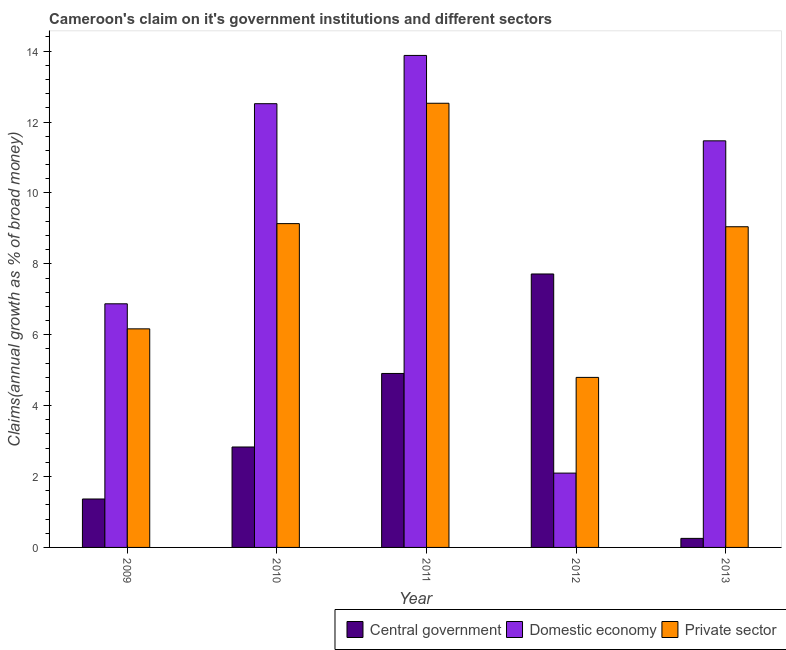How many groups of bars are there?
Your answer should be very brief. 5. Are the number of bars per tick equal to the number of legend labels?
Offer a very short reply. Yes. Are the number of bars on each tick of the X-axis equal?
Your answer should be compact. Yes. What is the percentage of claim on the private sector in 2013?
Your answer should be compact. 9.05. Across all years, what is the maximum percentage of claim on the private sector?
Offer a terse response. 12.53. Across all years, what is the minimum percentage of claim on the central government?
Your answer should be compact. 0.25. In which year was the percentage of claim on the private sector minimum?
Offer a terse response. 2012. What is the total percentage of claim on the private sector in the graph?
Your response must be concise. 41.67. What is the difference between the percentage of claim on the private sector in 2009 and that in 2010?
Ensure brevity in your answer.  -2.97. What is the difference between the percentage of claim on the private sector in 2011 and the percentage of claim on the central government in 2012?
Keep it short and to the point. 7.73. What is the average percentage of claim on the domestic economy per year?
Your response must be concise. 9.37. In the year 2010, what is the difference between the percentage of claim on the private sector and percentage of claim on the domestic economy?
Your answer should be very brief. 0. What is the ratio of the percentage of claim on the central government in 2009 to that in 2012?
Provide a succinct answer. 0.18. What is the difference between the highest and the second highest percentage of claim on the domestic economy?
Provide a short and direct response. 1.36. What is the difference between the highest and the lowest percentage of claim on the private sector?
Provide a short and direct response. 7.73. In how many years, is the percentage of claim on the private sector greater than the average percentage of claim on the private sector taken over all years?
Provide a succinct answer. 3. What does the 1st bar from the left in 2013 represents?
Ensure brevity in your answer.  Central government. What does the 2nd bar from the right in 2011 represents?
Your response must be concise. Domestic economy. How many bars are there?
Make the answer very short. 15. How many years are there in the graph?
Your answer should be compact. 5. What is the difference between two consecutive major ticks on the Y-axis?
Your answer should be compact. 2. What is the title of the graph?
Keep it short and to the point. Cameroon's claim on it's government institutions and different sectors. What is the label or title of the X-axis?
Make the answer very short. Year. What is the label or title of the Y-axis?
Give a very brief answer. Claims(annual growth as % of broad money). What is the Claims(annual growth as % of broad money) in Central government in 2009?
Give a very brief answer. 1.37. What is the Claims(annual growth as % of broad money) of Domestic economy in 2009?
Keep it short and to the point. 6.87. What is the Claims(annual growth as % of broad money) of Private sector in 2009?
Offer a very short reply. 6.17. What is the Claims(annual growth as % of broad money) in Central government in 2010?
Keep it short and to the point. 2.83. What is the Claims(annual growth as % of broad money) in Domestic economy in 2010?
Offer a terse response. 12.52. What is the Claims(annual growth as % of broad money) in Private sector in 2010?
Your answer should be compact. 9.13. What is the Claims(annual growth as % of broad money) in Central government in 2011?
Offer a terse response. 4.91. What is the Claims(annual growth as % of broad money) in Domestic economy in 2011?
Your answer should be compact. 13.88. What is the Claims(annual growth as % of broad money) of Private sector in 2011?
Your answer should be compact. 12.53. What is the Claims(annual growth as % of broad money) of Central government in 2012?
Keep it short and to the point. 7.71. What is the Claims(annual growth as % of broad money) in Domestic economy in 2012?
Ensure brevity in your answer.  2.1. What is the Claims(annual growth as % of broad money) of Private sector in 2012?
Make the answer very short. 4.8. What is the Claims(annual growth as % of broad money) of Central government in 2013?
Provide a short and direct response. 0.25. What is the Claims(annual growth as % of broad money) of Domestic economy in 2013?
Provide a succinct answer. 11.47. What is the Claims(annual growth as % of broad money) of Private sector in 2013?
Provide a short and direct response. 9.05. Across all years, what is the maximum Claims(annual growth as % of broad money) of Central government?
Your response must be concise. 7.71. Across all years, what is the maximum Claims(annual growth as % of broad money) of Domestic economy?
Offer a very short reply. 13.88. Across all years, what is the maximum Claims(annual growth as % of broad money) of Private sector?
Provide a succinct answer. 12.53. Across all years, what is the minimum Claims(annual growth as % of broad money) in Central government?
Provide a succinct answer. 0.25. Across all years, what is the minimum Claims(annual growth as % of broad money) of Domestic economy?
Provide a succinct answer. 2.1. Across all years, what is the minimum Claims(annual growth as % of broad money) in Private sector?
Your response must be concise. 4.8. What is the total Claims(annual growth as % of broad money) of Central government in the graph?
Provide a succinct answer. 17.08. What is the total Claims(annual growth as % of broad money) in Domestic economy in the graph?
Keep it short and to the point. 46.83. What is the total Claims(annual growth as % of broad money) of Private sector in the graph?
Keep it short and to the point. 41.67. What is the difference between the Claims(annual growth as % of broad money) in Central government in 2009 and that in 2010?
Ensure brevity in your answer.  -1.47. What is the difference between the Claims(annual growth as % of broad money) in Domestic economy in 2009 and that in 2010?
Ensure brevity in your answer.  -5.64. What is the difference between the Claims(annual growth as % of broad money) of Private sector in 2009 and that in 2010?
Keep it short and to the point. -2.97. What is the difference between the Claims(annual growth as % of broad money) of Central government in 2009 and that in 2011?
Give a very brief answer. -3.54. What is the difference between the Claims(annual growth as % of broad money) of Domestic economy in 2009 and that in 2011?
Offer a terse response. -7.01. What is the difference between the Claims(annual growth as % of broad money) in Private sector in 2009 and that in 2011?
Your answer should be compact. -6.36. What is the difference between the Claims(annual growth as % of broad money) of Central government in 2009 and that in 2012?
Your answer should be very brief. -6.35. What is the difference between the Claims(annual growth as % of broad money) in Domestic economy in 2009 and that in 2012?
Your answer should be compact. 4.78. What is the difference between the Claims(annual growth as % of broad money) in Private sector in 2009 and that in 2012?
Ensure brevity in your answer.  1.37. What is the difference between the Claims(annual growth as % of broad money) in Central government in 2009 and that in 2013?
Give a very brief answer. 1.11. What is the difference between the Claims(annual growth as % of broad money) of Domestic economy in 2009 and that in 2013?
Make the answer very short. -4.6. What is the difference between the Claims(annual growth as % of broad money) in Private sector in 2009 and that in 2013?
Ensure brevity in your answer.  -2.88. What is the difference between the Claims(annual growth as % of broad money) in Central government in 2010 and that in 2011?
Ensure brevity in your answer.  -2.07. What is the difference between the Claims(annual growth as % of broad money) of Domestic economy in 2010 and that in 2011?
Make the answer very short. -1.36. What is the difference between the Claims(annual growth as % of broad money) of Private sector in 2010 and that in 2011?
Ensure brevity in your answer.  -3.4. What is the difference between the Claims(annual growth as % of broad money) in Central government in 2010 and that in 2012?
Ensure brevity in your answer.  -4.88. What is the difference between the Claims(annual growth as % of broad money) in Domestic economy in 2010 and that in 2012?
Your answer should be compact. 10.42. What is the difference between the Claims(annual growth as % of broad money) of Private sector in 2010 and that in 2012?
Your answer should be very brief. 4.34. What is the difference between the Claims(annual growth as % of broad money) of Central government in 2010 and that in 2013?
Provide a short and direct response. 2.58. What is the difference between the Claims(annual growth as % of broad money) in Domestic economy in 2010 and that in 2013?
Your answer should be compact. 1.05. What is the difference between the Claims(annual growth as % of broad money) in Private sector in 2010 and that in 2013?
Ensure brevity in your answer.  0.09. What is the difference between the Claims(annual growth as % of broad money) in Central government in 2011 and that in 2012?
Provide a short and direct response. -2.81. What is the difference between the Claims(annual growth as % of broad money) in Domestic economy in 2011 and that in 2012?
Your answer should be compact. 11.78. What is the difference between the Claims(annual growth as % of broad money) of Private sector in 2011 and that in 2012?
Keep it short and to the point. 7.73. What is the difference between the Claims(annual growth as % of broad money) in Central government in 2011 and that in 2013?
Your answer should be very brief. 4.65. What is the difference between the Claims(annual growth as % of broad money) of Domestic economy in 2011 and that in 2013?
Offer a very short reply. 2.41. What is the difference between the Claims(annual growth as % of broad money) in Private sector in 2011 and that in 2013?
Keep it short and to the point. 3.48. What is the difference between the Claims(annual growth as % of broad money) of Central government in 2012 and that in 2013?
Provide a short and direct response. 7.46. What is the difference between the Claims(annual growth as % of broad money) in Domestic economy in 2012 and that in 2013?
Your answer should be compact. -9.37. What is the difference between the Claims(annual growth as % of broad money) in Private sector in 2012 and that in 2013?
Provide a short and direct response. -4.25. What is the difference between the Claims(annual growth as % of broad money) in Central government in 2009 and the Claims(annual growth as % of broad money) in Domestic economy in 2010?
Give a very brief answer. -11.15. What is the difference between the Claims(annual growth as % of broad money) of Central government in 2009 and the Claims(annual growth as % of broad money) of Private sector in 2010?
Provide a short and direct response. -7.77. What is the difference between the Claims(annual growth as % of broad money) in Domestic economy in 2009 and the Claims(annual growth as % of broad money) in Private sector in 2010?
Your answer should be very brief. -2.26. What is the difference between the Claims(annual growth as % of broad money) of Central government in 2009 and the Claims(annual growth as % of broad money) of Domestic economy in 2011?
Offer a very short reply. -12.51. What is the difference between the Claims(annual growth as % of broad money) in Central government in 2009 and the Claims(annual growth as % of broad money) in Private sector in 2011?
Offer a terse response. -11.16. What is the difference between the Claims(annual growth as % of broad money) in Domestic economy in 2009 and the Claims(annual growth as % of broad money) in Private sector in 2011?
Provide a succinct answer. -5.66. What is the difference between the Claims(annual growth as % of broad money) of Central government in 2009 and the Claims(annual growth as % of broad money) of Domestic economy in 2012?
Make the answer very short. -0.73. What is the difference between the Claims(annual growth as % of broad money) in Central government in 2009 and the Claims(annual growth as % of broad money) in Private sector in 2012?
Your response must be concise. -3.43. What is the difference between the Claims(annual growth as % of broad money) in Domestic economy in 2009 and the Claims(annual growth as % of broad money) in Private sector in 2012?
Make the answer very short. 2.08. What is the difference between the Claims(annual growth as % of broad money) in Central government in 2009 and the Claims(annual growth as % of broad money) in Domestic economy in 2013?
Keep it short and to the point. -10.1. What is the difference between the Claims(annual growth as % of broad money) in Central government in 2009 and the Claims(annual growth as % of broad money) in Private sector in 2013?
Your response must be concise. -7.68. What is the difference between the Claims(annual growth as % of broad money) of Domestic economy in 2009 and the Claims(annual growth as % of broad money) of Private sector in 2013?
Offer a very short reply. -2.17. What is the difference between the Claims(annual growth as % of broad money) of Central government in 2010 and the Claims(annual growth as % of broad money) of Domestic economy in 2011?
Ensure brevity in your answer.  -11.05. What is the difference between the Claims(annual growth as % of broad money) in Central government in 2010 and the Claims(annual growth as % of broad money) in Private sector in 2011?
Keep it short and to the point. -9.7. What is the difference between the Claims(annual growth as % of broad money) in Domestic economy in 2010 and the Claims(annual growth as % of broad money) in Private sector in 2011?
Ensure brevity in your answer.  -0.01. What is the difference between the Claims(annual growth as % of broad money) of Central government in 2010 and the Claims(annual growth as % of broad money) of Domestic economy in 2012?
Your answer should be compact. 0.74. What is the difference between the Claims(annual growth as % of broad money) of Central government in 2010 and the Claims(annual growth as % of broad money) of Private sector in 2012?
Offer a very short reply. -1.96. What is the difference between the Claims(annual growth as % of broad money) of Domestic economy in 2010 and the Claims(annual growth as % of broad money) of Private sector in 2012?
Provide a succinct answer. 7.72. What is the difference between the Claims(annual growth as % of broad money) in Central government in 2010 and the Claims(annual growth as % of broad money) in Domestic economy in 2013?
Give a very brief answer. -8.64. What is the difference between the Claims(annual growth as % of broad money) in Central government in 2010 and the Claims(annual growth as % of broad money) in Private sector in 2013?
Ensure brevity in your answer.  -6.21. What is the difference between the Claims(annual growth as % of broad money) of Domestic economy in 2010 and the Claims(annual growth as % of broad money) of Private sector in 2013?
Provide a short and direct response. 3.47. What is the difference between the Claims(annual growth as % of broad money) in Central government in 2011 and the Claims(annual growth as % of broad money) in Domestic economy in 2012?
Give a very brief answer. 2.81. What is the difference between the Claims(annual growth as % of broad money) of Central government in 2011 and the Claims(annual growth as % of broad money) of Private sector in 2012?
Provide a short and direct response. 0.11. What is the difference between the Claims(annual growth as % of broad money) in Domestic economy in 2011 and the Claims(annual growth as % of broad money) in Private sector in 2012?
Give a very brief answer. 9.08. What is the difference between the Claims(annual growth as % of broad money) in Central government in 2011 and the Claims(annual growth as % of broad money) in Domestic economy in 2013?
Make the answer very short. -6.56. What is the difference between the Claims(annual growth as % of broad money) in Central government in 2011 and the Claims(annual growth as % of broad money) in Private sector in 2013?
Keep it short and to the point. -4.14. What is the difference between the Claims(annual growth as % of broad money) of Domestic economy in 2011 and the Claims(annual growth as % of broad money) of Private sector in 2013?
Give a very brief answer. 4.83. What is the difference between the Claims(annual growth as % of broad money) of Central government in 2012 and the Claims(annual growth as % of broad money) of Domestic economy in 2013?
Give a very brief answer. -3.76. What is the difference between the Claims(annual growth as % of broad money) of Central government in 2012 and the Claims(annual growth as % of broad money) of Private sector in 2013?
Offer a very short reply. -1.33. What is the difference between the Claims(annual growth as % of broad money) of Domestic economy in 2012 and the Claims(annual growth as % of broad money) of Private sector in 2013?
Offer a terse response. -6.95. What is the average Claims(annual growth as % of broad money) of Central government per year?
Ensure brevity in your answer.  3.42. What is the average Claims(annual growth as % of broad money) in Domestic economy per year?
Your answer should be very brief. 9.37. What is the average Claims(annual growth as % of broad money) in Private sector per year?
Ensure brevity in your answer.  8.33. In the year 2009, what is the difference between the Claims(annual growth as % of broad money) in Central government and Claims(annual growth as % of broad money) in Domestic economy?
Provide a short and direct response. -5.51. In the year 2009, what is the difference between the Claims(annual growth as % of broad money) of Central government and Claims(annual growth as % of broad money) of Private sector?
Your answer should be very brief. -4.8. In the year 2009, what is the difference between the Claims(annual growth as % of broad money) in Domestic economy and Claims(annual growth as % of broad money) in Private sector?
Make the answer very short. 0.71. In the year 2010, what is the difference between the Claims(annual growth as % of broad money) of Central government and Claims(annual growth as % of broad money) of Domestic economy?
Make the answer very short. -9.68. In the year 2010, what is the difference between the Claims(annual growth as % of broad money) in Central government and Claims(annual growth as % of broad money) in Private sector?
Your answer should be very brief. -6.3. In the year 2010, what is the difference between the Claims(annual growth as % of broad money) in Domestic economy and Claims(annual growth as % of broad money) in Private sector?
Ensure brevity in your answer.  3.38. In the year 2011, what is the difference between the Claims(annual growth as % of broad money) in Central government and Claims(annual growth as % of broad money) in Domestic economy?
Your response must be concise. -8.97. In the year 2011, what is the difference between the Claims(annual growth as % of broad money) in Central government and Claims(annual growth as % of broad money) in Private sector?
Ensure brevity in your answer.  -7.62. In the year 2011, what is the difference between the Claims(annual growth as % of broad money) in Domestic economy and Claims(annual growth as % of broad money) in Private sector?
Give a very brief answer. 1.35. In the year 2012, what is the difference between the Claims(annual growth as % of broad money) of Central government and Claims(annual growth as % of broad money) of Domestic economy?
Offer a terse response. 5.62. In the year 2012, what is the difference between the Claims(annual growth as % of broad money) in Central government and Claims(annual growth as % of broad money) in Private sector?
Your answer should be compact. 2.92. In the year 2012, what is the difference between the Claims(annual growth as % of broad money) in Domestic economy and Claims(annual growth as % of broad money) in Private sector?
Make the answer very short. -2.7. In the year 2013, what is the difference between the Claims(annual growth as % of broad money) of Central government and Claims(annual growth as % of broad money) of Domestic economy?
Your response must be concise. -11.21. In the year 2013, what is the difference between the Claims(annual growth as % of broad money) of Central government and Claims(annual growth as % of broad money) of Private sector?
Ensure brevity in your answer.  -8.79. In the year 2013, what is the difference between the Claims(annual growth as % of broad money) of Domestic economy and Claims(annual growth as % of broad money) of Private sector?
Provide a short and direct response. 2.42. What is the ratio of the Claims(annual growth as % of broad money) in Central government in 2009 to that in 2010?
Offer a very short reply. 0.48. What is the ratio of the Claims(annual growth as % of broad money) of Domestic economy in 2009 to that in 2010?
Make the answer very short. 0.55. What is the ratio of the Claims(annual growth as % of broad money) of Private sector in 2009 to that in 2010?
Provide a succinct answer. 0.68. What is the ratio of the Claims(annual growth as % of broad money) of Central government in 2009 to that in 2011?
Offer a terse response. 0.28. What is the ratio of the Claims(annual growth as % of broad money) of Domestic economy in 2009 to that in 2011?
Your answer should be very brief. 0.5. What is the ratio of the Claims(annual growth as % of broad money) in Private sector in 2009 to that in 2011?
Provide a succinct answer. 0.49. What is the ratio of the Claims(annual growth as % of broad money) in Central government in 2009 to that in 2012?
Ensure brevity in your answer.  0.18. What is the ratio of the Claims(annual growth as % of broad money) of Domestic economy in 2009 to that in 2012?
Your answer should be compact. 3.28. What is the ratio of the Claims(annual growth as % of broad money) in Private sector in 2009 to that in 2012?
Your answer should be very brief. 1.29. What is the ratio of the Claims(annual growth as % of broad money) of Central government in 2009 to that in 2013?
Offer a very short reply. 5.36. What is the ratio of the Claims(annual growth as % of broad money) of Domestic economy in 2009 to that in 2013?
Offer a terse response. 0.6. What is the ratio of the Claims(annual growth as % of broad money) of Private sector in 2009 to that in 2013?
Keep it short and to the point. 0.68. What is the ratio of the Claims(annual growth as % of broad money) of Central government in 2010 to that in 2011?
Your response must be concise. 0.58. What is the ratio of the Claims(annual growth as % of broad money) in Domestic economy in 2010 to that in 2011?
Your answer should be very brief. 0.9. What is the ratio of the Claims(annual growth as % of broad money) in Private sector in 2010 to that in 2011?
Provide a succinct answer. 0.73. What is the ratio of the Claims(annual growth as % of broad money) in Central government in 2010 to that in 2012?
Make the answer very short. 0.37. What is the ratio of the Claims(annual growth as % of broad money) in Domestic economy in 2010 to that in 2012?
Make the answer very short. 5.97. What is the ratio of the Claims(annual growth as % of broad money) in Private sector in 2010 to that in 2012?
Your answer should be compact. 1.9. What is the ratio of the Claims(annual growth as % of broad money) of Central government in 2010 to that in 2013?
Your response must be concise. 11.11. What is the ratio of the Claims(annual growth as % of broad money) in Domestic economy in 2010 to that in 2013?
Make the answer very short. 1.09. What is the ratio of the Claims(annual growth as % of broad money) of Private sector in 2010 to that in 2013?
Give a very brief answer. 1.01. What is the ratio of the Claims(annual growth as % of broad money) in Central government in 2011 to that in 2012?
Provide a succinct answer. 0.64. What is the ratio of the Claims(annual growth as % of broad money) in Domestic economy in 2011 to that in 2012?
Provide a succinct answer. 6.62. What is the ratio of the Claims(annual growth as % of broad money) of Private sector in 2011 to that in 2012?
Provide a succinct answer. 2.61. What is the ratio of the Claims(annual growth as % of broad money) in Central government in 2011 to that in 2013?
Your answer should be compact. 19.25. What is the ratio of the Claims(annual growth as % of broad money) of Domestic economy in 2011 to that in 2013?
Offer a terse response. 1.21. What is the ratio of the Claims(annual growth as % of broad money) of Private sector in 2011 to that in 2013?
Keep it short and to the point. 1.39. What is the ratio of the Claims(annual growth as % of broad money) in Central government in 2012 to that in 2013?
Provide a succinct answer. 30.25. What is the ratio of the Claims(annual growth as % of broad money) in Domestic economy in 2012 to that in 2013?
Your response must be concise. 0.18. What is the ratio of the Claims(annual growth as % of broad money) of Private sector in 2012 to that in 2013?
Keep it short and to the point. 0.53. What is the difference between the highest and the second highest Claims(annual growth as % of broad money) in Central government?
Ensure brevity in your answer.  2.81. What is the difference between the highest and the second highest Claims(annual growth as % of broad money) in Domestic economy?
Offer a very short reply. 1.36. What is the difference between the highest and the second highest Claims(annual growth as % of broad money) of Private sector?
Provide a short and direct response. 3.4. What is the difference between the highest and the lowest Claims(annual growth as % of broad money) of Central government?
Offer a very short reply. 7.46. What is the difference between the highest and the lowest Claims(annual growth as % of broad money) in Domestic economy?
Ensure brevity in your answer.  11.78. What is the difference between the highest and the lowest Claims(annual growth as % of broad money) of Private sector?
Your answer should be compact. 7.73. 